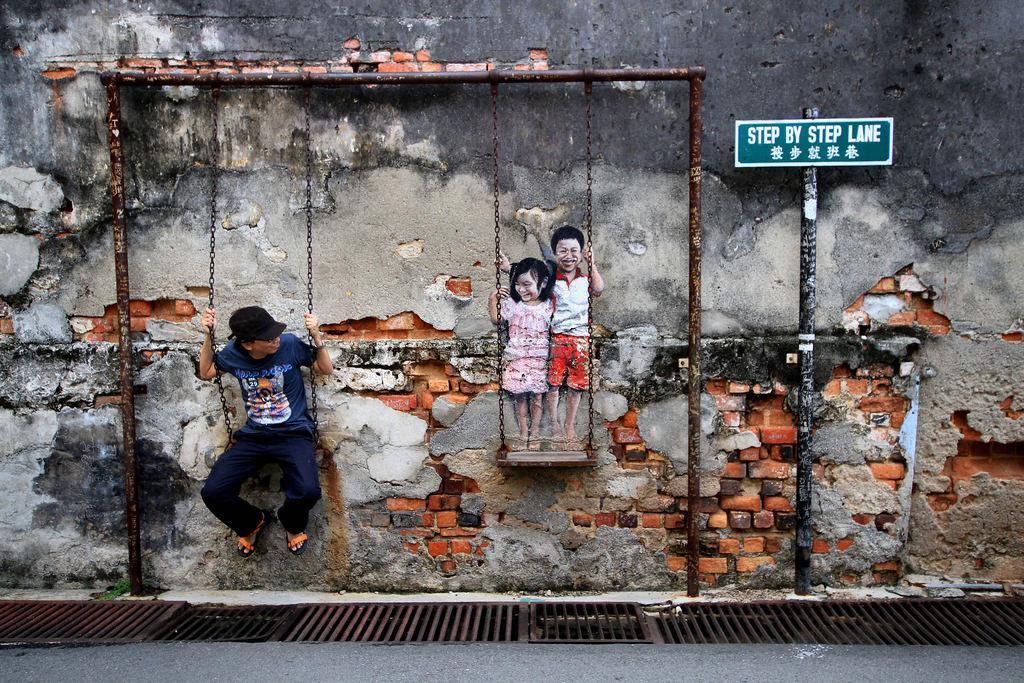Describe this image in one or two sentences. This picture is clicked outside. On the right there is a green color board attached to the pole and we can see the two kids standing on a swing. On the left there is a person wearing blue color t-shirt and sitting on the swing. In the background we can see the metal rods and a wall. 